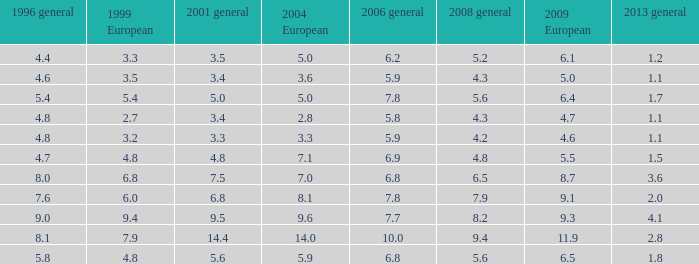What is the mean value considering 2001 general with over 4.8 in 1999 european, 7.7 in 2006 general, and above 9 in 1996 general? None. 